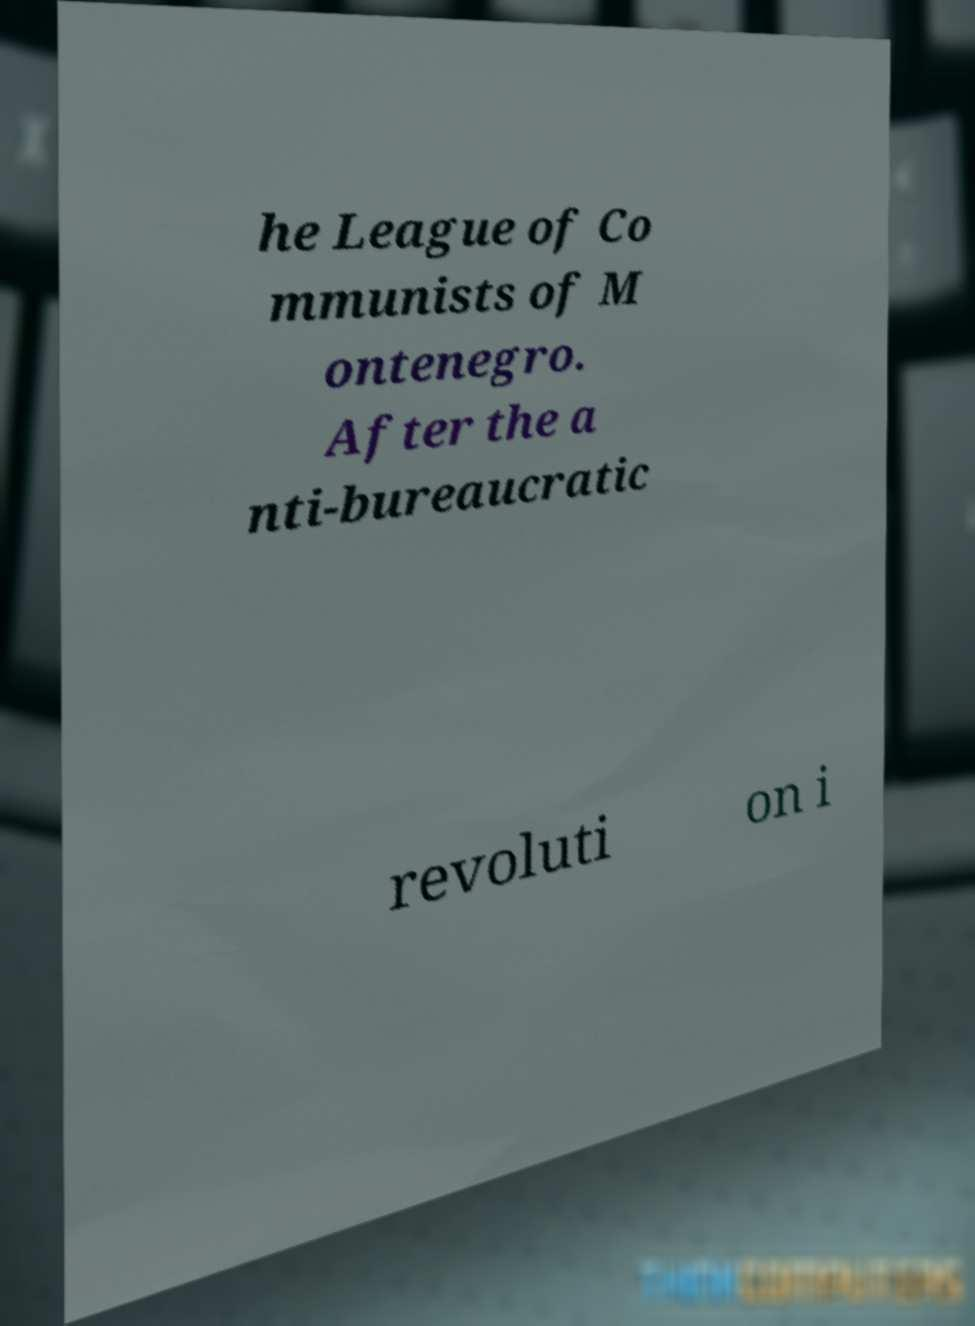I need the written content from this picture converted into text. Can you do that? he League of Co mmunists of M ontenegro. After the a nti-bureaucratic revoluti on i 